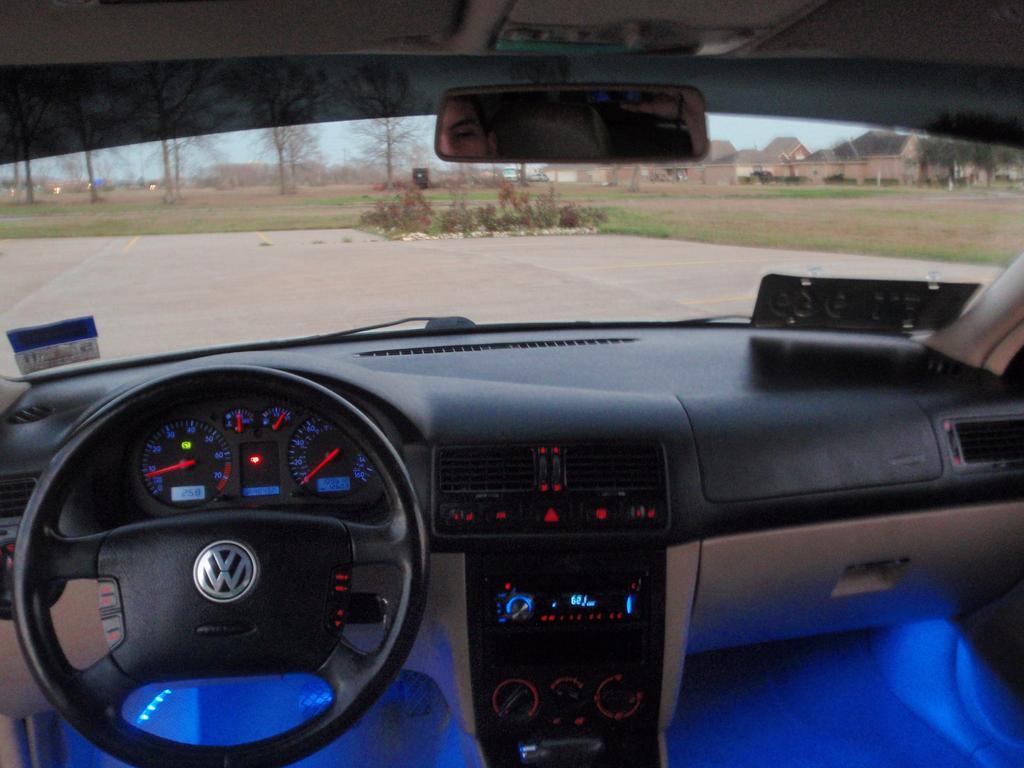In one or two sentences, can you explain what this image depicts? This picture is taken from inside of a car , as we can see there is a steering at the bottom left side of this image , as we can see there are some trees at the top of this image. 